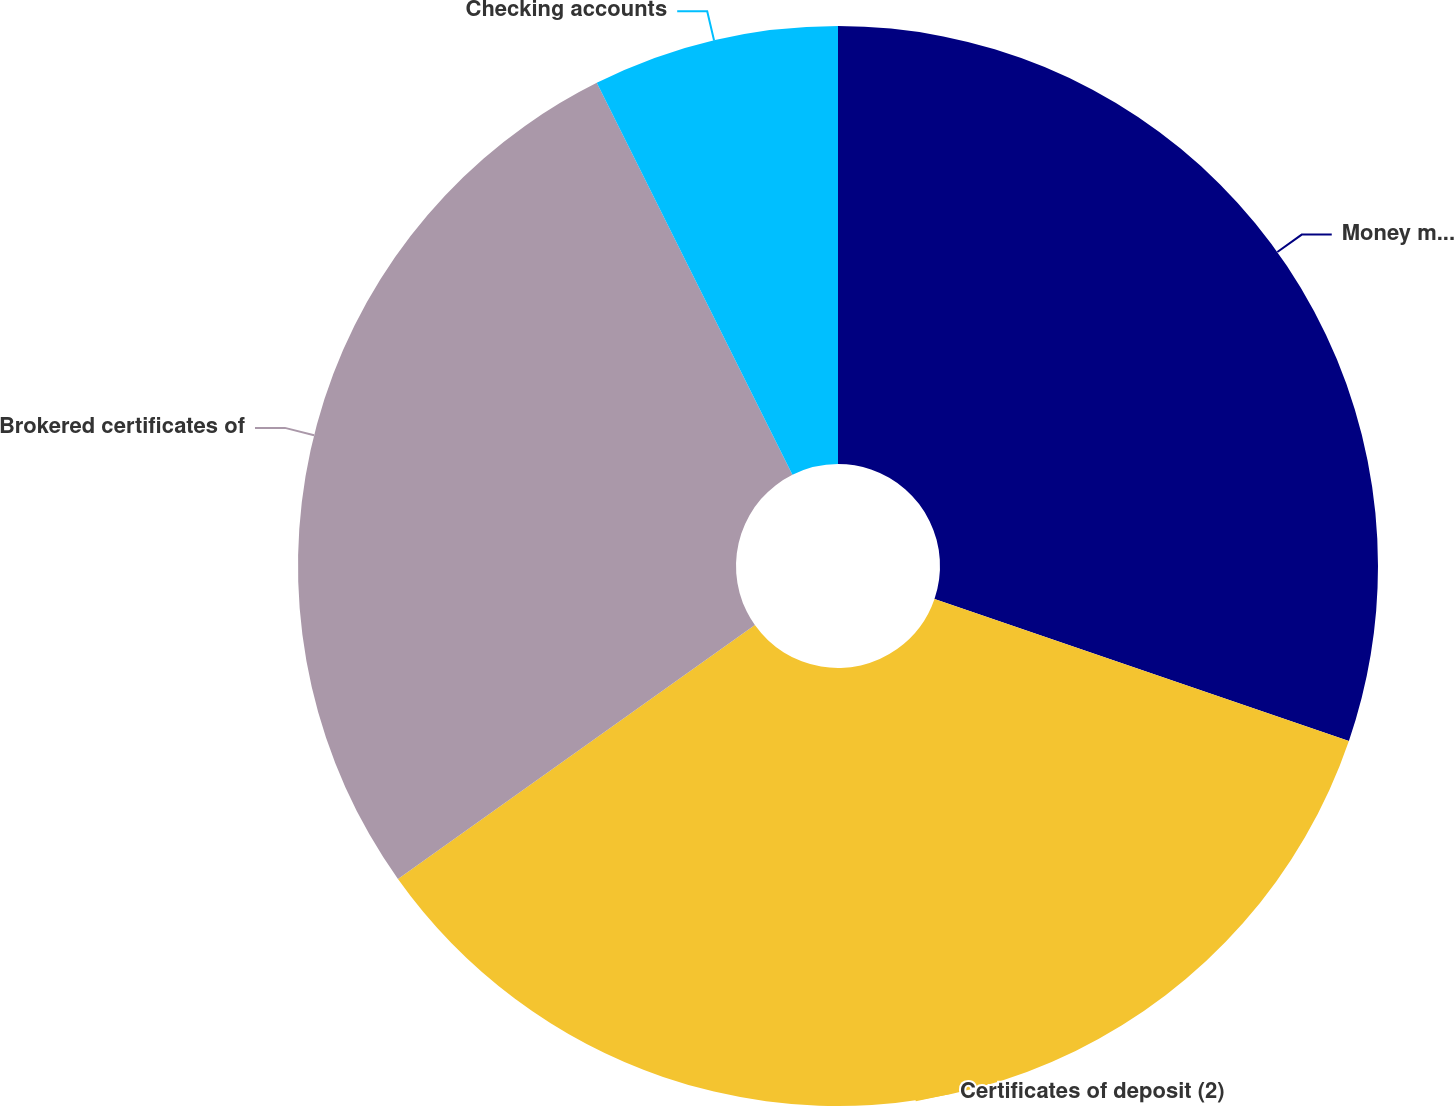<chart> <loc_0><loc_0><loc_500><loc_500><pie_chart><fcel>Money market and savings<fcel>Certificates of deposit (2)<fcel>Brokered certificates of<fcel>Checking accounts<nl><fcel>30.25%<fcel>34.91%<fcel>27.47%<fcel>7.37%<nl></chart> 